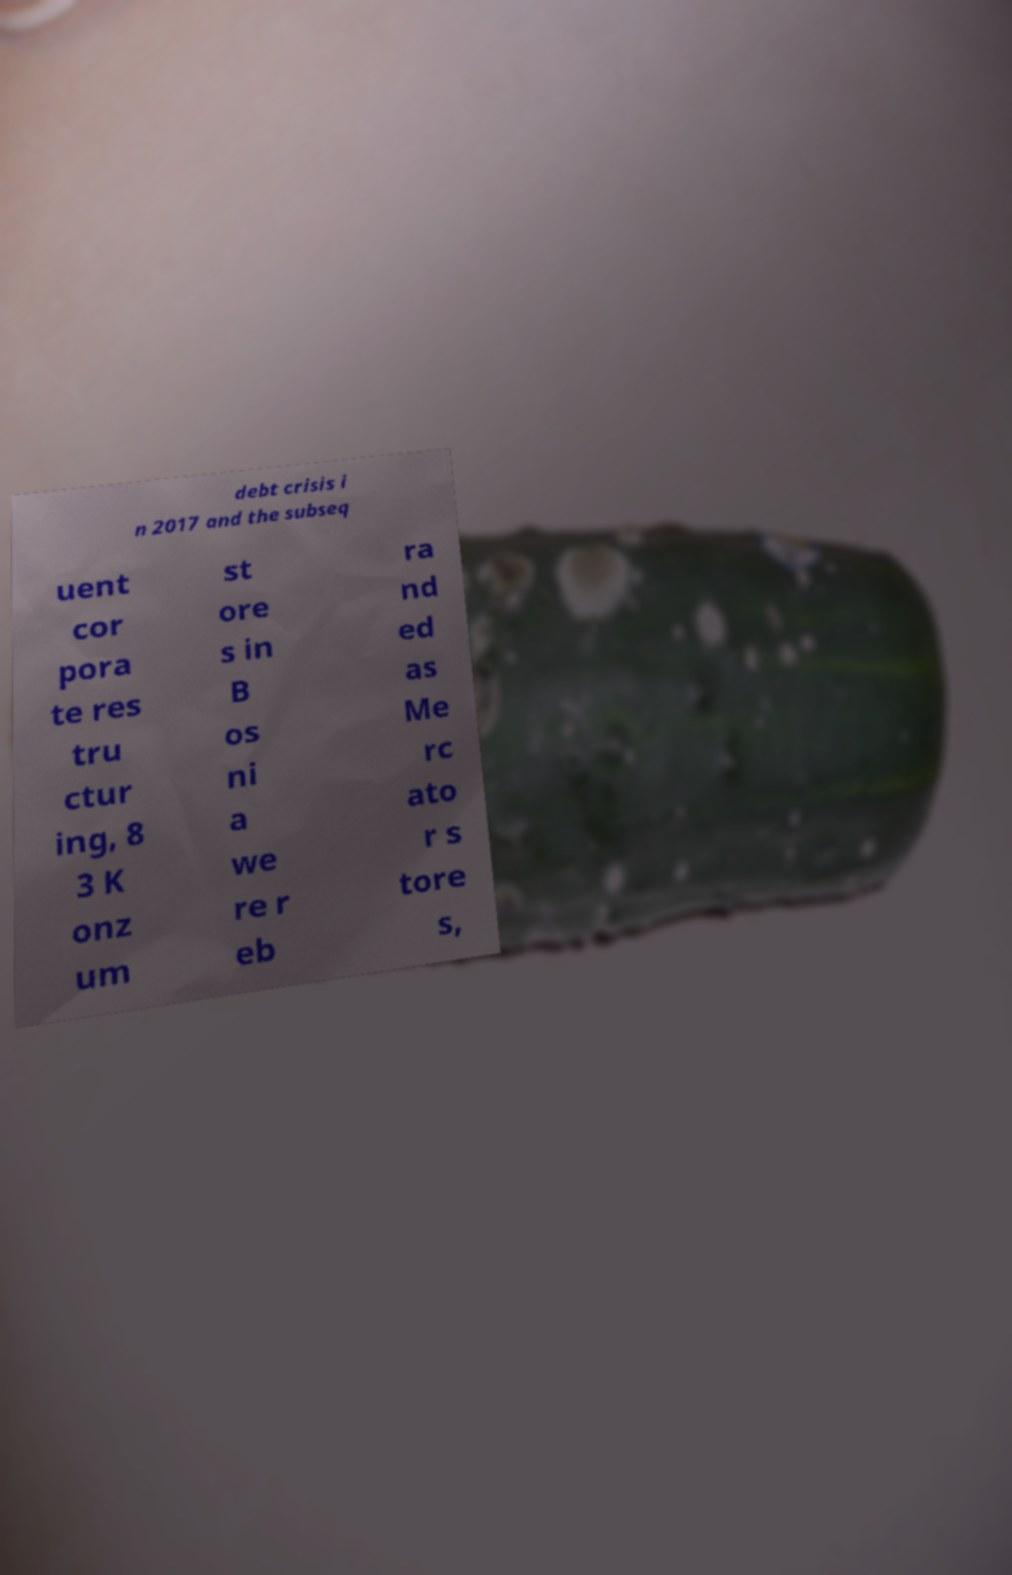Can you read and provide the text displayed in the image?This photo seems to have some interesting text. Can you extract and type it out for me? debt crisis i n 2017 and the subseq uent cor pora te res tru ctur ing, 8 3 K onz um st ore s in B os ni a we re r eb ra nd ed as Me rc ato r s tore s, 